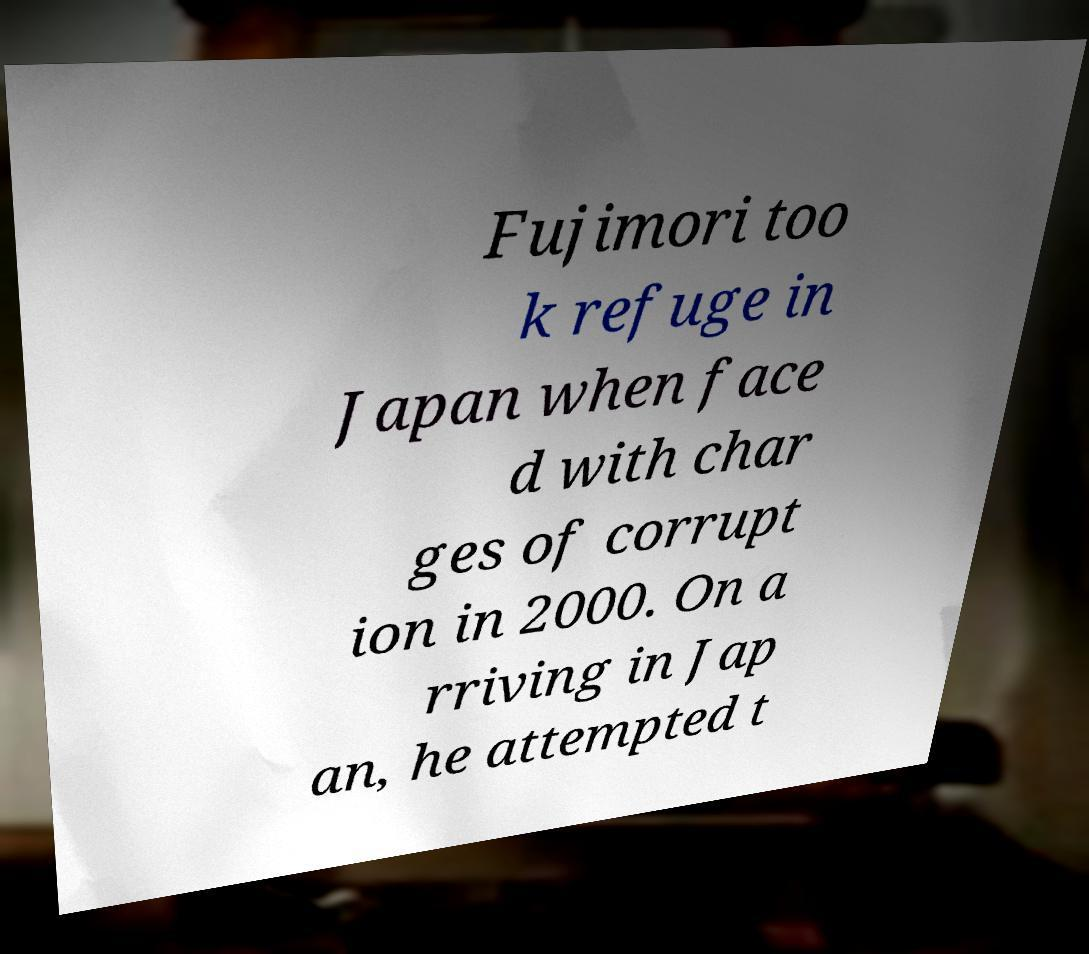Can you read and provide the text displayed in the image?This photo seems to have some interesting text. Can you extract and type it out for me? Fujimori too k refuge in Japan when face d with char ges of corrupt ion in 2000. On a rriving in Jap an, he attempted t 